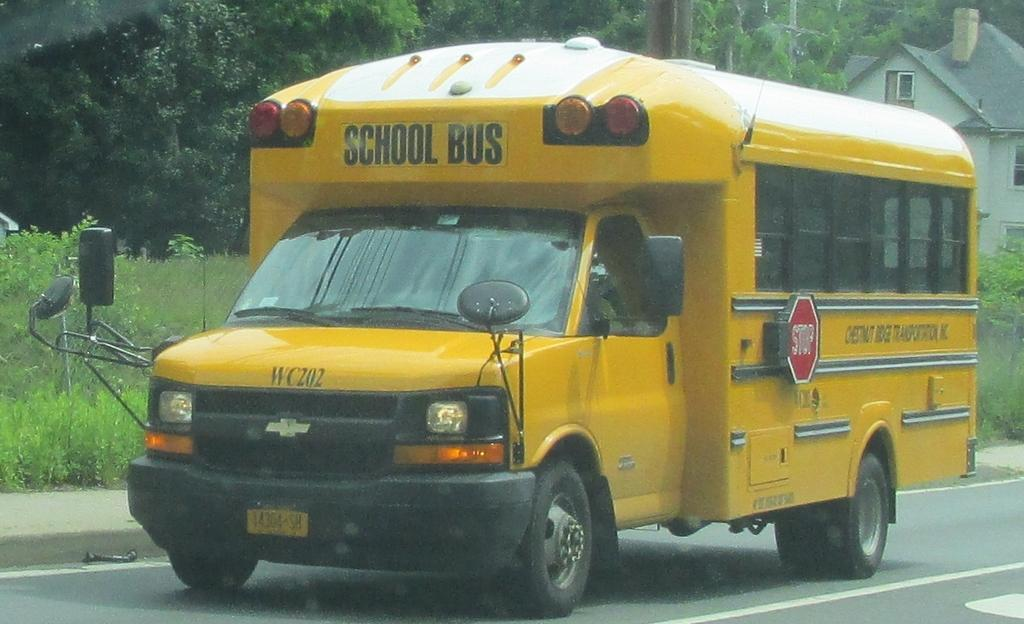What type of vehicle is in the image? There is a yellow school bus in the image. What is the school bus doing in the image? The school bus is moving on the road. What can be seen in the background of the image? There are trees and a white shed house visible in the background. What is the price of the scarf being worn by the driver of the school bus in the image? There is no scarf or driver visible in the image, so it is not possible to determine the price of a scarf. 